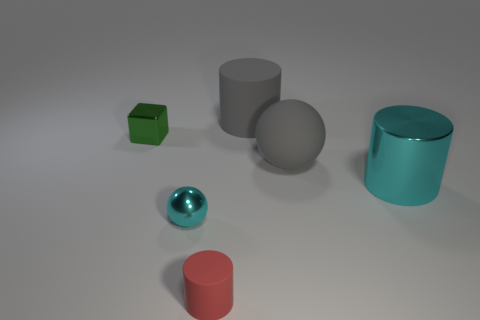Subtract all large cylinders. How many cylinders are left? 1 Add 2 green blocks. How many objects exist? 8 Subtract all blocks. How many objects are left? 5 Add 4 shiny cylinders. How many shiny cylinders exist? 5 Subtract 0 cyan cubes. How many objects are left? 6 Subtract all tiny gray balls. Subtract all big shiny objects. How many objects are left? 5 Add 1 large cyan metal objects. How many large cyan metal objects are left? 2 